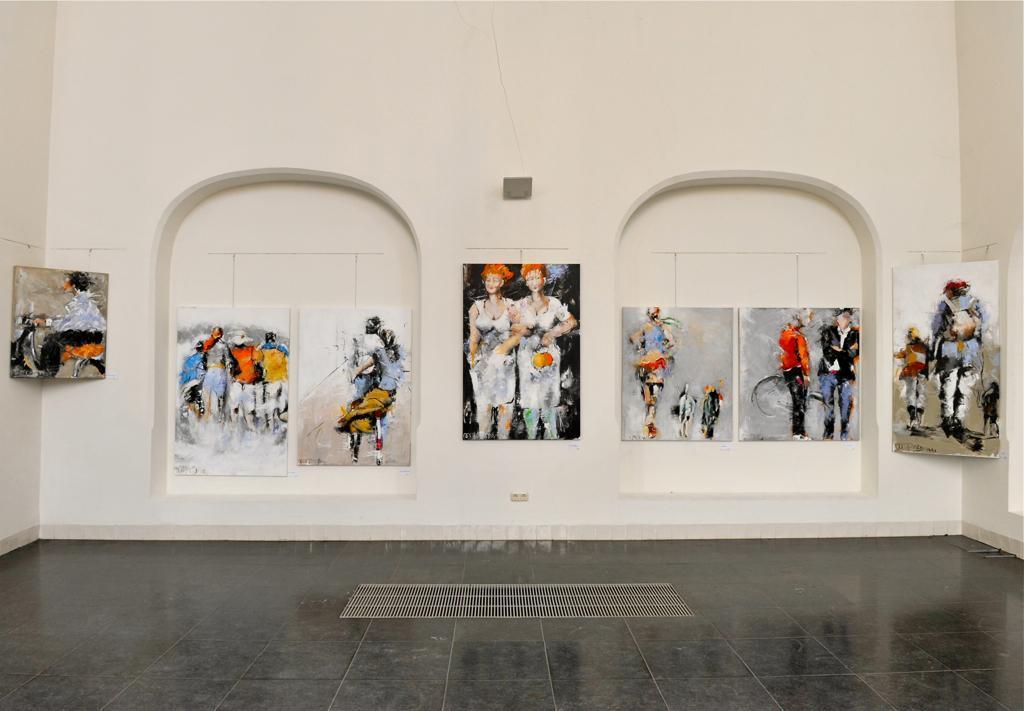In one or two sentences, can you explain what this image depicts? In this image we can see some photo frames of painting on the wall, also we can see the light and a power socket. 